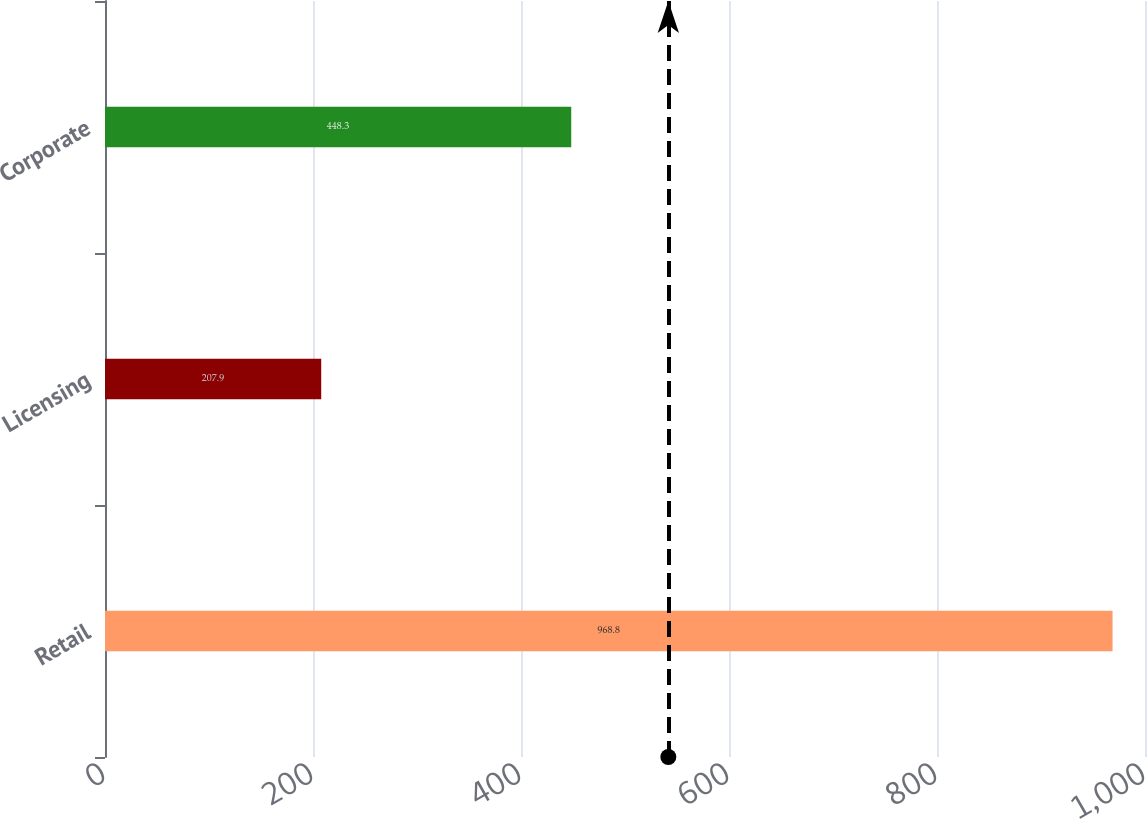Convert chart. <chart><loc_0><loc_0><loc_500><loc_500><bar_chart><fcel>Retail<fcel>Licensing<fcel>Corporate<nl><fcel>968.8<fcel>207.9<fcel>448.3<nl></chart> 